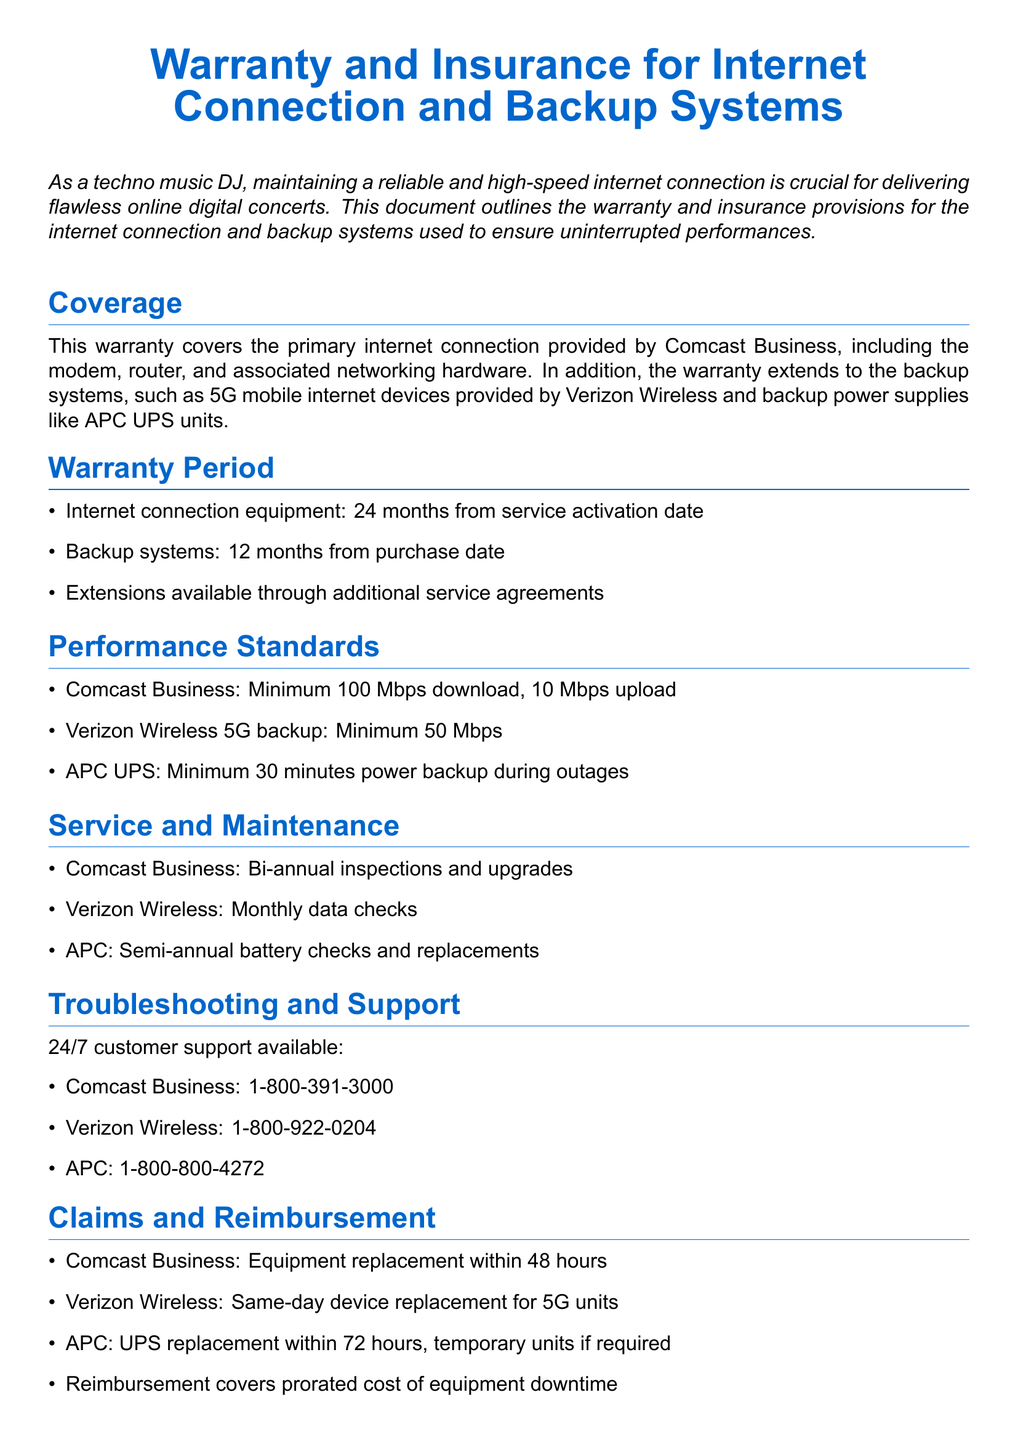what is the warranty period for internet connection equipment? The warranty period for internet connection equipment is stated in the document as 24 months from service activation date.
Answer: 24 months what is the minimum upload speed for Comcast Business? The document specifies that the minimum upload speed for Comcast Business is 10 Mbps.
Answer: 10 Mbps how often are inspections conducted for Comcast Business services? The document outlines that inspections for Comcast Business are conducted bi-annually.
Answer: Bi-annual what is the performance standard for the APC UPS? The performance standard for the APC UPS is set at a minimum of 30 minutes power backup during outages.
Answer: 30 minutes how long does Verizon Wireless take for 5G device replacement? According to the document, Verizon Wireless provides same-day device replacement for 5G units.
Answer: Same-day what is not covered by the warranty? The document lists that the warranty does not cover damages due to natural disasters, unauthorized modifications, or misuse of equipment.
Answer: Natural disasters how frequently are battery checks conducted for APC systems? The document states that battery checks for APC systems are conducted semi-annually.
Answer: Semi-annual what is the customer support number for Verizon Wireless? The document provides the customer support number for Verizon Wireless as 1-800-922-0204.
Answer: 1-800-922-0204 